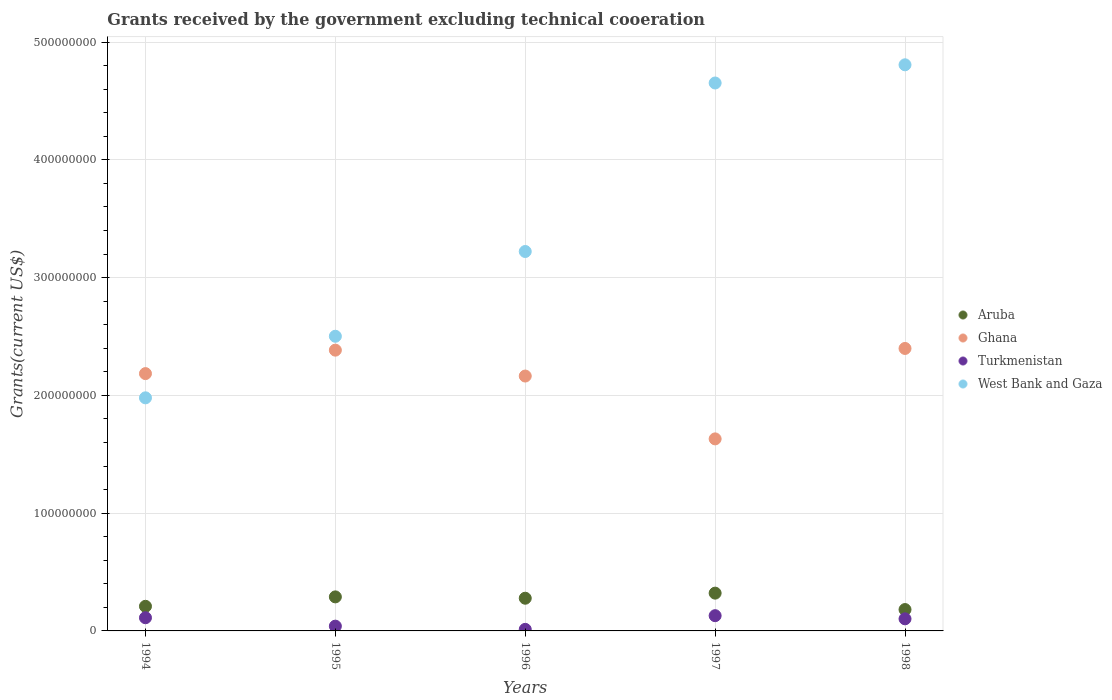Is the number of dotlines equal to the number of legend labels?
Give a very brief answer. Yes. What is the total grants received by the government in Aruba in 1994?
Your response must be concise. 2.09e+07. Across all years, what is the maximum total grants received by the government in Aruba?
Your answer should be very brief. 3.21e+07. Across all years, what is the minimum total grants received by the government in Aruba?
Give a very brief answer. 1.81e+07. What is the total total grants received by the government in Turkmenistan in the graph?
Your response must be concise. 3.98e+07. What is the difference between the total grants received by the government in West Bank and Gaza in 1994 and that in 1998?
Make the answer very short. -2.83e+08. What is the difference between the total grants received by the government in Turkmenistan in 1995 and the total grants received by the government in West Bank and Gaza in 1996?
Keep it short and to the point. -3.18e+08. What is the average total grants received by the government in Ghana per year?
Provide a short and direct response. 2.15e+08. In the year 1998, what is the difference between the total grants received by the government in Turkmenistan and total grants received by the government in West Bank and Gaza?
Offer a very short reply. -4.70e+08. In how many years, is the total grants received by the government in West Bank and Gaza greater than 240000000 US$?
Offer a terse response. 4. What is the ratio of the total grants received by the government in Turkmenistan in 1995 to that in 1996?
Give a very brief answer. 3.07. What is the difference between the highest and the second highest total grants received by the government in Turkmenistan?
Offer a very short reply. 1.75e+06. What is the difference between the highest and the lowest total grants received by the government in Turkmenistan?
Provide a succinct answer. 1.16e+07. Is it the case that in every year, the sum of the total grants received by the government in Ghana and total grants received by the government in Aruba  is greater than the sum of total grants received by the government in West Bank and Gaza and total grants received by the government in Turkmenistan?
Your response must be concise. No. Is it the case that in every year, the sum of the total grants received by the government in West Bank and Gaza and total grants received by the government in Ghana  is greater than the total grants received by the government in Turkmenistan?
Your answer should be very brief. Yes. Does the total grants received by the government in Aruba monotonically increase over the years?
Provide a short and direct response. No. Is the total grants received by the government in Aruba strictly less than the total grants received by the government in Turkmenistan over the years?
Provide a succinct answer. No. How many dotlines are there?
Provide a succinct answer. 4. How many years are there in the graph?
Your answer should be very brief. 5. Are the values on the major ticks of Y-axis written in scientific E-notation?
Offer a very short reply. No. What is the title of the graph?
Offer a very short reply. Grants received by the government excluding technical cooeration. Does "United States" appear as one of the legend labels in the graph?
Ensure brevity in your answer.  No. What is the label or title of the Y-axis?
Offer a very short reply. Grants(current US$). What is the Grants(current US$) of Aruba in 1994?
Provide a succinct answer. 2.09e+07. What is the Grants(current US$) in Ghana in 1994?
Provide a short and direct response. 2.18e+08. What is the Grants(current US$) of Turkmenistan in 1994?
Your answer should be compact. 1.12e+07. What is the Grants(current US$) in West Bank and Gaza in 1994?
Your answer should be compact. 1.98e+08. What is the Grants(current US$) in Aruba in 1995?
Provide a succinct answer. 2.89e+07. What is the Grants(current US$) of Ghana in 1995?
Ensure brevity in your answer.  2.38e+08. What is the Grants(current US$) of Turkmenistan in 1995?
Your answer should be compact. 4.05e+06. What is the Grants(current US$) in West Bank and Gaza in 1995?
Ensure brevity in your answer.  2.50e+08. What is the Grants(current US$) in Aruba in 1996?
Provide a succinct answer. 2.78e+07. What is the Grants(current US$) in Ghana in 1996?
Offer a terse response. 2.16e+08. What is the Grants(current US$) of Turkmenistan in 1996?
Provide a short and direct response. 1.32e+06. What is the Grants(current US$) in West Bank and Gaza in 1996?
Your answer should be very brief. 3.22e+08. What is the Grants(current US$) of Aruba in 1997?
Keep it short and to the point. 3.21e+07. What is the Grants(current US$) in Ghana in 1997?
Ensure brevity in your answer.  1.63e+08. What is the Grants(current US$) in Turkmenistan in 1997?
Your answer should be very brief. 1.29e+07. What is the Grants(current US$) in West Bank and Gaza in 1997?
Your response must be concise. 4.65e+08. What is the Grants(current US$) in Aruba in 1998?
Offer a terse response. 1.81e+07. What is the Grants(current US$) of Ghana in 1998?
Your answer should be very brief. 2.40e+08. What is the Grants(current US$) of Turkmenistan in 1998?
Provide a succinct answer. 1.03e+07. What is the Grants(current US$) in West Bank and Gaza in 1998?
Provide a short and direct response. 4.81e+08. Across all years, what is the maximum Grants(current US$) of Aruba?
Keep it short and to the point. 3.21e+07. Across all years, what is the maximum Grants(current US$) of Ghana?
Provide a short and direct response. 2.40e+08. Across all years, what is the maximum Grants(current US$) in Turkmenistan?
Your answer should be very brief. 1.29e+07. Across all years, what is the maximum Grants(current US$) of West Bank and Gaza?
Your answer should be compact. 4.81e+08. Across all years, what is the minimum Grants(current US$) in Aruba?
Give a very brief answer. 1.81e+07. Across all years, what is the minimum Grants(current US$) of Ghana?
Your answer should be compact. 1.63e+08. Across all years, what is the minimum Grants(current US$) of Turkmenistan?
Your answer should be compact. 1.32e+06. Across all years, what is the minimum Grants(current US$) in West Bank and Gaza?
Provide a short and direct response. 1.98e+08. What is the total Grants(current US$) in Aruba in the graph?
Your answer should be very brief. 1.28e+08. What is the total Grants(current US$) in Ghana in the graph?
Make the answer very short. 1.08e+09. What is the total Grants(current US$) in Turkmenistan in the graph?
Provide a short and direct response. 3.98e+07. What is the total Grants(current US$) of West Bank and Gaza in the graph?
Keep it short and to the point. 1.72e+09. What is the difference between the Grants(current US$) of Aruba in 1994 and that in 1995?
Provide a succinct answer. -8.00e+06. What is the difference between the Grants(current US$) in Ghana in 1994 and that in 1995?
Your response must be concise. -1.99e+07. What is the difference between the Grants(current US$) of Turkmenistan in 1994 and that in 1995?
Your answer should be very brief. 7.14e+06. What is the difference between the Grants(current US$) of West Bank and Gaza in 1994 and that in 1995?
Your response must be concise. -5.23e+07. What is the difference between the Grants(current US$) of Aruba in 1994 and that in 1996?
Give a very brief answer. -6.86e+06. What is the difference between the Grants(current US$) of Ghana in 1994 and that in 1996?
Your answer should be compact. 2.07e+06. What is the difference between the Grants(current US$) in Turkmenistan in 1994 and that in 1996?
Give a very brief answer. 9.87e+06. What is the difference between the Grants(current US$) in West Bank and Gaza in 1994 and that in 1996?
Ensure brevity in your answer.  -1.24e+08. What is the difference between the Grants(current US$) of Aruba in 1994 and that in 1997?
Make the answer very short. -1.12e+07. What is the difference between the Grants(current US$) of Ghana in 1994 and that in 1997?
Your answer should be very brief. 5.54e+07. What is the difference between the Grants(current US$) of Turkmenistan in 1994 and that in 1997?
Give a very brief answer. -1.75e+06. What is the difference between the Grants(current US$) in West Bank and Gaza in 1994 and that in 1997?
Provide a succinct answer. -2.67e+08. What is the difference between the Grants(current US$) in Aruba in 1994 and that in 1998?
Provide a succinct answer. 2.76e+06. What is the difference between the Grants(current US$) of Ghana in 1994 and that in 1998?
Make the answer very short. -2.14e+07. What is the difference between the Grants(current US$) in Turkmenistan in 1994 and that in 1998?
Offer a terse response. 9.20e+05. What is the difference between the Grants(current US$) of West Bank and Gaza in 1994 and that in 1998?
Provide a succinct answer. -2.83e+08. What is the difference between the Grants(current US$) of Aruba in 1995 and that in 1996?
Provide a succinct answer. 1.14e+06. What is the difference between the Grants(current US$) in Ghana in 1995 and that in 1996?
Your answer should be compact. 2.20e+07. What is the difference between the Grants(current US$) of Turkmenistan in 1995 and that in 1996?
Ensure brevity in your answer.  2.73e+06. What is the difference between the Grants(current US$) in West Bank and Gaza in 1995 and that in 1996?
Provide a succinct answer. -7.20e+07. What is the difference between the Grants(current US$) of Aruba in 1995 and that in 1997?
Offer a very short reply. -3.18e+06. What is the difference between the Grants(current US$) in Ghana in 1995 and that in 1997?
Make the answer very short. 7.54e+07. What is the difference between the Grants(current US$) in Turkmenistan in 1995 and that in 1997?
Your answer should be compact. -8.89e+06. What is the difference between the Grants(current US$) of West Bank and Gaza in 1995 and that in 1997?
Your response must be concise. -2.15e+08. What is the difference between the Grants(current US$) in Aruba in 1995 and that in 1998?
Make the answer very short. 1.08e+07. What is the difference between the Grants(current US$) in Ghana in 1995 and that in 1998?
Your answer should be compact. -1.44e+06. What is the difference between the Grants(current US$) in Turkmenistan in 1995 and that in 1998?
Your answer should be compact. -6.22e+06. What is the difference between the Grants(current US$) in West Bank and Gaza in 1995 and that in 1998?
Provide a short and direct response. -2.30e+08. What is the difference between the Grants(current US$) of Aruba in 1996 and that in 1997?
Offer a very short reply. -4.32e+06. What is the difference between the Grants(current US$) of Ghana in 1996 and that in 1997?
Your answer should be compact. 5.34e+07. What is the difference between the Grants(current US$) in Turkmenistan in 1996 and that in 1997?
Your response must be concise. -1.16e+07. What is the difference between the Grants(current US$) in West Bank and Gaza in 1996 and that in 1997?
Your answer should be very brief. -1.43e+08. What is the difference between the Grants(current US$) in Aruba in 1996 and that in 1998?
Keep it short and to the point. 9.62e+06. What is the difference between the Grants(current US$) of Ghana in 1996 and that in 1998?
Offer a terse response. -2.34e+07. What is the difference between the Grants(current US$) in Turkmenistan in 1996 and that in 1998?
Ensure brevity in your answer.  -8.95e+06. What is the difference between the Grants(current US$) in West Bank and Gaza in 1996 and that in 1998?
Provide a succinct answer. -1.59e+08. What is the difference between the Grants(current US$) in Aruba in 1997 and that in 1998?
Your answer should be compact. 1.39e+07. What is the difference between the Grants(current US$) in Ghana in 1997 and that in 1998?
Provide a short and direct response. -7.68e+07. What is the difference between the Grants(current US$) of Turkmenistan in 1997 and that in 1998?
Offer a terse response. 2.67e+06. What is the difference between the Grants(current US$) in West Bank and Gaza in 1997 and that in 1998?
Give a very brief answer. -1.54e+07. What is the difference between the Grants(current US$) in Aruba in 1994 and the Grants(current US$) in Ghana in 1995?
Make the answer very short. -2.18e+08. What is the difference between the Grants(current US$) of Aruba in 1994 and the Grants(current US$) of Turkmenistan in 1995?
Your answer should be very brief. 1.68e+07. What is the difference between the Grants(current US$) in Aruba in 1994 and the Grants(current US$) in West Bank and Gaza in 1995?
Offer a terse response. -2.29e+08. What is the difference between the Grants(current US$) in Ghana in 1994 and the Grants(current US$) in Turkmenistan in 1995?
Provide a short and direct response. 2.14e+08. What is the difference between the Grants(current US$) in Ghana in 1994 and the Grants(current US$) in West Bank and Gaza in 1995?
Your answer should be compact. -3.17e+07. What is the difference between the Grants(current US$) of Turkmenistan in 1994 and the Grants(current US$) of West Bank and Gaza in 1995?
Provide a short and direct response. -2.39e+08. What is the difference between the Grants(current US$) in Aruba in 1994 and the Grants(current US$) in Ghana in 1996?
Give a very brief answer. -1.96e+08. What is the difference between the Grants(current US$) of Aruba in 1994 and the Grants(current US$) of Turkmenistan in 1996?
Your answer should be very brief. 1.96e+07. What is the difference between the Grants(current US$) in Aruba in 1994 and the Grants(current US$) in West Bank and Gaza in 1996?
Keep it short and to the point. -3.01e+08. What is the difference between the Grants(current US$) of Ghana in 1994 and the Grants(current US$) of Turkmenistan in 1996?
Your response must be concise. 2.17e+08. What is the difference between the Grants(current US$) of Ghana in 1994 and the Grants(current US$) of West Bank and Gaza in 1996?
Your answer should be very brief. -1.04e+08. What is the difference between the Grants(current US$) of Turkmenistan in 1994 and the Grants(current US$) of West Bank and Gaza in 1996?
Your answer should be very brief. -3.11e+08. What is the difference between the Grants(current US$) of Aruba in 1994 and the Grants(current US$) of Ghana in 1997?
Your response must be concise. -1.42e+08. What is the difference between the Grants(current US$) of Aruba in 1994 and the Grants(current US$) of Turkmenistan in 1997?
Make the answer very short. 7.96e+06. What is the difference between the Grants(current US$) of Aruba in 1994 and the Grants(current US$) of West Bank and Gaza in 1997?
Offer a very short reply. -4.44e+08. What is the difference between the Grants(current US$) in Ghana in 1994 and the Grants(current US$) in Turkmenistan in 1997?
Your answer should be compact. 2.06e+08. What is the difference between the Grants(current US$) in Ghana in 1994 and the Grants(current US$) in West Bank and Gaza in 1997?
Offer a terse response. -2.47e+08. What is the difference between the Grants(current US$) in Turkmenistan in 1994 and the Grants(current US$) in West Bank and Gaza in 1997?
Offer a very short reply. -4.54e+08. What is the difference between the Grants(current US$) in Aruba in 1994 and the Grants(current US$) in Ghana in 1998?
Your answer should be very brief. -2.19e+08. What is the difference between the Grants(current US$) of Aruba in 1994 and the Grants(current US$) of Turkmenistan in 1998?
Offer a terse response. 1.06e+07. What is the difference between the Grants(current US$) of Aruba in 1994 and the Grants(current US$) of West Bank and Gaza in 1998?
Your answer should be compact. -4.60e+08. What is the difference between the Grants(current US$) of Ghana in 1994 and the Grants(current US$) of Turkmenistan in 1998?
Offer a very short reply. 2.08e+08. What is the difference between the Grants(current US$) in Ghana in 1994 and the Grants(current US$) in West Bank and Gaza in 1998?
Offer a very short reply. -2.62e+08. What is the difference between the Grants(current US$) of Turkmenistan in 1994 and the Grants(current US$) of West Bank and Gaza in 1998?
Keep it short and to the point. -4.69e+08. What is the difference between the Grants(current US$) of Aruba in 1995 and the Grants(current US$) of Ghana in 1996?
Make the answer very short. -1.88e+08. What is the difference between the Grants(current US$) in Aruba in 1995 and the Grants(current US$) in Turkmenistan in 1996?
Your response must be concise. 2.76e+07. What is the difference between the Grants(current US$) in Aruba in 1995 and the Grants(current US$) in West Bank and Gaza in 1996?
Provide a succinct answer. -2.93e+08. What is the difference between the Grants(current US$) of Ghana in 1995 and the Grants(current US$) of Turkmenistan in 1996?
Offer a very short reply. 2.37e+08. What is the difference between the Grants(current US$) in Ghana in 1995 and the Grants(current US$) in West Bank and Gaza in 1996?
Make the answer very short. -8.38e+07. What is the difference between the Grants(current US$) of Turkmenistan in 1995 and the Grants(current US$) of West Bank and Gaza in 1996?
Your answer should be very brief. -3.18e+08. What is the difference between the Grants(current US$) in Aruba in 1995 and the Grants(current US$) in Ghana in 1997?
Ensure brevity in your answer.  -1.34e+08. What is the difference between the Grants(current US$) in Aruba in 1995 and the Grants(current US$) in Turkmenistan in 1997?
Keep it short and to the point. 1.60e+07. What is the difference between the Grants(current US$) in Aruba in 1995 and the Grants(current US$) in West Bank and Gaza in 1997?
Provide a short and direct response. -4.36e+08. What is the difference between the Grants(current US$) in Ghana in 1995 and the Grants(current US$) in Turkmenistan in 1997?
Offer a terse response. 2.25e+08. What is the difference between the Grants(current US$) of Ghana in 1995 and the Grants(current US$) of West Bank and Gaza in 1997?
Your response must be concise. -2.27e+08. What is the difference between the Grants(current US$) of Turkmenistan in 1995 and the Grants(current US$) of West Bank and Gaza in 1997?
Give a very brief answer. -4.61e+08. What is the difference between the Grants(current US$) of Aruba in 1995 and the Grants(current US$) of Ghana in 1998?
Your answer should be very brief. -2.11e+08. What is the difference between the Grants(current US$) in Aruba in 1995 and the Grants(current US$) in Turkmenistan in 1998?
Make the answer very short. 1.86e+07. What is the difference between the Grants(current US$) in Aruba in 1995 and the Grants(current US$) in West Bank and Gaza in 1998?
Offer a terse response. -4.52e+08. What is the difference between the Grants(current US$) in Ghana in 1995 and the Grants(current US$) in Turkmenistan in 1998?
Your answer should be very brief. 2.28e+08. What is the difference between the Grants(current US$) of Ghana in 1995 and the Grants(current US$) of West Bank and Gaza in 1998?
Provide a short and direct response. -2.42e+08. What is the difference between the Grants(current US$) of Turkmenistan in 1995 and the Grants(current US$) of West Bank and Gaza in 1998?
Provide a short and direct response. -4.77e+08. What is the difference between the Grants(current US$) in Aruba in 1996 and the Grants(current US$) in Ghana in 1997?
Make the answer very short. -1.35e+08. What is the difference between the Grants(current US$) of Aruba in 1996 and the Grants(current US$) of Turkmenistan in 1997?
Offer a terse response. 1.48e+07. What is the difference between the Grants(current US$) in Aruba in 1996 and the Grants(current US$) in West Bank and Gaza in 1997?
Offer a terse response. -4.37e+08. What is the difference between the Grants(current US$) in Ghana in 1996 and the Grants(current US$) in Turkmenistan in 1997?
Provide a succinct answer. 2.03e+08. What is the difference between the Grants(current US$) of Ghana in 1996 and the Grants(current US$) of West Bank and Gaza in 1997?
Provide a short and direct response. -2.49e+08. What is the difference between the Grants(current US$) in Turkmenistan in 1996 and the Grants(current US$) in West Bank and Gaza in 1997?
Your answer should be compact. -4.64e+08. What is the difference between the Grants(current US$) in Aruba in 1996 and the Grants(current US$) in Ghana in 1998?
Provide a succinct answer. -2.12e+08. What is the difference between the Grants(current US$) of Aruba in 1996 and the Grants(current US$) of Turkmenistan in 1998?
Your response must be concise. 1.75e+07. What is the difference between the Grants(current US$) of Aruba in 1996 and the Grants(current US$) of West Bank and Gaza in 1998?
Offer a very short reply. -4.53e+08. What is the difference between the Grants(current US$) of Ghana in 1996 and the Grants(current US$) of Turkmenistan in 1998?
Your answer should be very brief. 2.06e+08. What is the difference between the Grants(current US$) of Ghana in 1996 and the Grants(current US$) of West Bank and Gaza in 1998?
Provide a succinct answer. -2.64e+08. What is the difference between the Grants(current US$) of Turkmenistan in 1996 and the Grants(current US$) of West Bank and Gaza in 1998?
Make the answer very short. -4.79e+08. What is the difference between the Grants(current US$) of Aruba in 1997 and the Grants(current US$) of Ghana in 1998?
Your answer should be compact. -2.08e+08. What is the difference between the Grants(current US$) of Aruba in 1997 and the Grants(current US$) of Turkmenistan in 1998?
Your answer should be compact. 2.18e+07. What is the difference between the Grants(current US$) in Aruba in 1997 and the Grants(current US$) in West Bank and Gaza in 1998?
Give a very brief answer. -4.49e+08. What is the difference between the Grants(current US$) of Ghana in 1997 and the Grants(current US$) of Turkmenistan in 1998?
Provide a short and direct response. 1.53e+08. What is the difference between the Grants(current US$) in Ghana in 1997 and the Grants(current US$) in West Bank and Gaza in 1998?
Your answer should be compact. -3.18e+08. What is the difference between the Grants(current US$) in Turkmenistan in 1997 and the Grants(current US$) in West Bank and Gaza in 1998?
Make the answer very short. -4.68e+08. What is the average Grants(current US$) in Aruba per year?
Give a very brief answer. 2.56e+07. What is the average Grants(current US$) of Ghana per year?
Offer a terse response. 2.15e+08. What is the average Grants(current US$) of Turkmenistan per year?
Make the answer very short. 7.95e+06. What is the average Grants(current US$) in West Bank and Gaza per year?
Keep it short and to the point. 3.43e+08. In the year 1994, what is the difference between the Grants(current US$) in Aruba and Grants(current US$) in Ghana?
Offer a terse response. -1.98e+08. In the year 1994, what is the difference between the Grants(current US$) of Aruba and Grants(current US$) of Turkmenistan?
Give a very brief answer. 9.71e+06. In the year 1994, what is the difference between the Grants(current US$) in Aruba and Grants(current US$) in West Bank and Gaza?
Ensure brevity in your answer.  -1.77e+08. In the year 1994, what is the difference between the Grants(current US$) in Ghana and Grants(current US$) in Turkmenistan?
Offer a terse response. 2.07e+08. In the year 1994, what is the difference between the Grants(current US$) of Ghana and Grants(current US$) of West Bank and Gaza?
Your answer should be compact. 2.06e+07. In the year 1994, what is the difference between the Grants(current US$) of Turkmenistan and Grants(current US$) of West Bank and Gaza?
Keep it short and to the point. -1.87e+08. In the year 1995, what is the difference between the Grants(current US$) of Aruba and Grants(current US$) of Ghana?
Your answer should be very brief. -2.10e+08. In the year 1995, what is the difference between the Grants(current US$) of Aruba and Grants(current US$) of Turkmenistan?
Give a very brief answer. 2.48e+07. In the year 1995, what is the difference between the Grants(current US$) in Aruba and Grants(current US$) in West Bank and Gaza?
Provide a short and direct response. -2.21e+08. In the year 1995, what is the difference between the Grants(current US$) of Ghana and Grants(current US$) of Turkmenistan?
Provide a short and direct response. 2.34e+08. In the year 1995, what is the difference between the Grants(current US$) of Ghana and Grants(current US$) of West Bank and Gaza?
Provide a short and direct response. -1.18e+07. In the year 1995, what is the difference between the Grants(current US$) of Turkmenistan and Grants(current US$) of West Bank and Gaza?
Ensure brevity in your answer.  -2.46e+08. In the year 1996, what is the difference between the Grants(current US$) of Aruba and Grants(current US$) of Ghana?
Keep it short and to the point. -1.89e+08. In the year 1996, what is the difference between the Grants(current US$) of Aruba and Grants(current US$) of Turkmenistan?
Your answer should be compact. 2.64e+07. In the year 1996, what is the difference between the Grants(current US$) of Aruba and Grants(current US$) of West Bank and Gaza?
Your answer should be compact. -2.94e+08. In the year 1996, what is the difference between the Grants(current US$) of Ghana and Grants(current US$) of Turkmenistan?
Your answer should be compact. 2.15e+08. In the year 1996, what is the difference between the Grants(current US$) in Ghana and Grants(current US$) in West Bank and Gaza?
Make the answer very short. -1.06e+08. In the year 1996, what is the difference between the Grants(current US$) of Turkmenistan and Grants(current US$) of West Bank and Gaza?
Give a very brief answer. -3.21e+08. In the year 1997, what is the difference between the Grants(current US$) in Aruba and Grants(current US$) in Ghana?
Your response must be concise. -1.31e+08. In the year 1997, what is the difference between the Grants(current US$) in Aruba and Grants(current US$) in Turkmenistan?
Your answer should be compact. 1.91e+07. In the year 1997, what is the difference between the Grants(current US$) in Aruba and Grants(current US$) in West Bank and Gaza?
Offer a very short reply. -4.33e+08. In the year 1997, what is the difference between the Grants(current US$) in Ghana and Grants(current US$) in Turkmenistan?
Offer a very short reply. 1.50e+08. In the year 1997, what is the difference between the Grants(current US$) in Ghana and Grants(current US$) in West Bank and Gaza?
Keep it short and to the point. -3.02e+08. In the year 1997, what is the difference between the Grants(current US$) of Turkmenistan and Grants(current US$) of West Bank and Gaza?
Keep it short and to the point. -4.52e+08. In the year 1998, what is the difference between the Grants(current US$) in Aruba and Grants(current US$) in Ghana?
Your answer should be very brief. -2.22e+08. In the year 1998, what is the difference between the Grants(current US$) in Aruba and Grants(current US$) in Turkmenistan?
Provide a short and direct response. 7.87e+06. In the year 1998, what is the difference between the Grants(current US$) in Aruba and Grants(current US$) in West Bank and Gaza?
Your answer should be compact. -4.63e+08. In the year 1998, what is the difference between the Grants(current US$) of Ghana and Grants(current US$) of Turkmenistan?
Your response must be concise. 2.30e+08. In the year 1998, what is the difference between the Grants(current US$) in Ghana and Grants(current US$) in West Bank and Gaza?
Your answer should be compact. -2.41e+08. In the year 1998, what is the difference between the Grants(current US$) in Turkmenistan and Grants(current US$) in West Bank and Gaza?
Ensure brevity in your answer.  -4.70e+08. What is the ratio of the Grants(current US$) in Aruba in 1994 to that in 1995?
Offer a very short reply. 0.72. What is the ratio of the Grants(current US$) in Ghana in 1994 to that in 1995?
Your answer should be compact. 0.92. What is the ratio of the Grants(current US$) of Turkmenistan in 1994 to that in 1995?
Provide a succinct answer. 2.76. What is the ratio of the Grants(current US$) in West Bank and Gaza in 1994 to that in 1995?
Provide a short and direct response. 0.79. What is the ratio of the Grants(current US$) in Aruba in 1994 to that in 1996?
Your answer should be very brief. 0.75. What is the ratio of the Grants(current US$) of Ghana in 1994 to that in 1996?
Provide a succinct answer. 1.01. What is the ratio of the Grants(current US$) in Turkmenistan in 1994 to that in 1996?
Your answer should be compact. 8.48. What is the ratio of the Grants(current US$) of West Bank and Gaza in 1994 to that in 1996?
Your response must be concise. 0.61. What is the ratio of the Grants(current US$) in Aruba in 1994 to that in 1997?
Your answer should be compact. 0.65. What is the ratio of the Grants(current US$) in Ghana in 1994 to that in 1997?
Make the answer very short. 1.34. What is the ratio of the Grants(current US$) of Turkmenistan in 1994 to that in 1997?
Provide a succinct answer. 0.86. What is the ratio of the Grants(current US$) in West Bank and Gaza in 1994 to that in 1997?
Your answer should be very brief. 0.43. What is the ratio of the Grants(current US$) of Aruba in 1994 to that in 1998?
Offer a terse response. 1.15. What is the ratio of the Grants(current US$) of Ghana in 1994 to that in 1998?
Keep it short and to the point. 0.91. What is the ratio of the Grants(current US$) of Turkmenistan in 1994 to that in 1998?
Provide a succinct answer. 1.09. What is the ratio of the Grants(current US$) in West Bank and Gaza in 1994 to that in 1998?
Offer a terse response. 0.41. What is the ratio of the Grants(current US$) in Aruba in 1995 to that in 1996?
Give a very brief answer. 1.04. What is the ratio of the Grants(current US$) in Ghana in 1995 to that in 1996?
Keep it short and to the point. 1.1. What is the ratio of the Grants(current US$) in Turkmenistan in 1995 to that in 1996?
Make the answer very short. 3.07. What is the ratio of the Grants(current US$) of West Bank and Gaza in 1995 to that in 1996?
Keep it short and to the point. 0.78. What is the ratio of the Grants(current US$) of Aruba in 1995 to that in 1997?
Provide a short and direct response. 0.9. What is the ratio of the Grants(current US$) of Ghana in 1995 to that in 1997?
Your answer should be compact. 1.46. What is the ratio of the Grants(current US$) of Turkmenistan in 1995 to that in 1997?
Make the answer very short. 0.31. What is the ratio of the Grants(current US$) in West Bank and Gaza in 1995 to that in 1997?
Keep it short and to the point. 0.54. What is the ratio of the Grants(current US$) of Aruba in 1995 to that in 1998?
Your response must be concise. 1.59. What is the ratio of the Grants(current US$) in Ghana in 1995 to that in 1998?
Give a very brief answer. 0.99. What is the ratio of the Grants(current US$) of Turkmenistan in 1995 to that in 1998?
Your answer should be compact. 0.39. What is the ratio of the Grants(current US$) in West Bank and Gaza in 1995 to that in 1998?
Keep it short and to the point. 0.52. What is the ratio of the Grants(current US$) in Aruba in 1996 to that in 1997?
Give a very brief answer. 0.87. What is the ratio of the Grants(current US$) of Ghana in 1996 to that in 1997?
Your answer should be compact. 1.33. What is the ratio of the Grants(current US$) of Turkmenistan in 1996 to that in 1997?
Give a very brief answer. 0.1. What is the ratio of the Grants(current US$) of West Bank and Gaza in 1996 to that in 1997?
Offer a terse response. 0.69. What is the ratio of the Grants(current US$) of Aruba in 1996 to that in 1998?
Your response must be concise. 1.53. What is the ratio of the Grants(current US$) in Ghana in 1996 to that in 1998?
Your response must be concise. 0.9. What is the ratio of the Grants(current US$) of Turkmenistan in 1996 to that in 1998?
Offer a very short reply. 0.13. What is the ratio of the Grants(current US$) of West Bank and Gaza in 1996 to that in 1998?
Ensure brevity in your answer.  0.67. What is the ratio of the Grants(current US$) in Aruba in 1997 to that in 1998?
Ensure brevity in your answer.  1.77. What is the ratio of the Grants(current US$) in Ghana in 1997 to that in 1998?
Make the answer very short. 0.68. What is the ratio of the Grants(current US$) of Turkmenistan in 1997 to that in 1998?
Provide a succinct answer. 1.26. What is the ratio of the Grants(current US$) in West Bank and Gaza in 1997 to that in 1998?
Your answer should be compact. 0.97. What is the difference between the highest and the second highest Grants(current US$) of Aruba?
Make the answer very short. 3.18e+06. What is the difference between the highest and the second highest Grants(current US$) of Ghana?
Your answer should be very brief. 1.44e+06. What is the difference between the highest and the second highest Grants(current US$) in Turkmenistan?
Give a very brief answer. 1.75e+06. What is the difference between the highest and the second highest Grants(current US$) of West Bank and Gaza?
Your answer should be compact. 1.54e+07. What is the difference between the highest and the lowest Grants(current US$) in Aruba?
Your answer should be compact. 1.39e+07. What is the difference between the highest and the lowest Grants(current US$) in Ghana?
Offer a terse response. 7.68e+07. What is the difference between the highest and the lowest Grants(current US$) of Turkmenistan?
Your answer should be compact. 1.16e+07. What is the difference between the highest and the lowest Grants(current US$) of West Bank and Gaza?
Provide a succinct answer. 2.83e+08. 